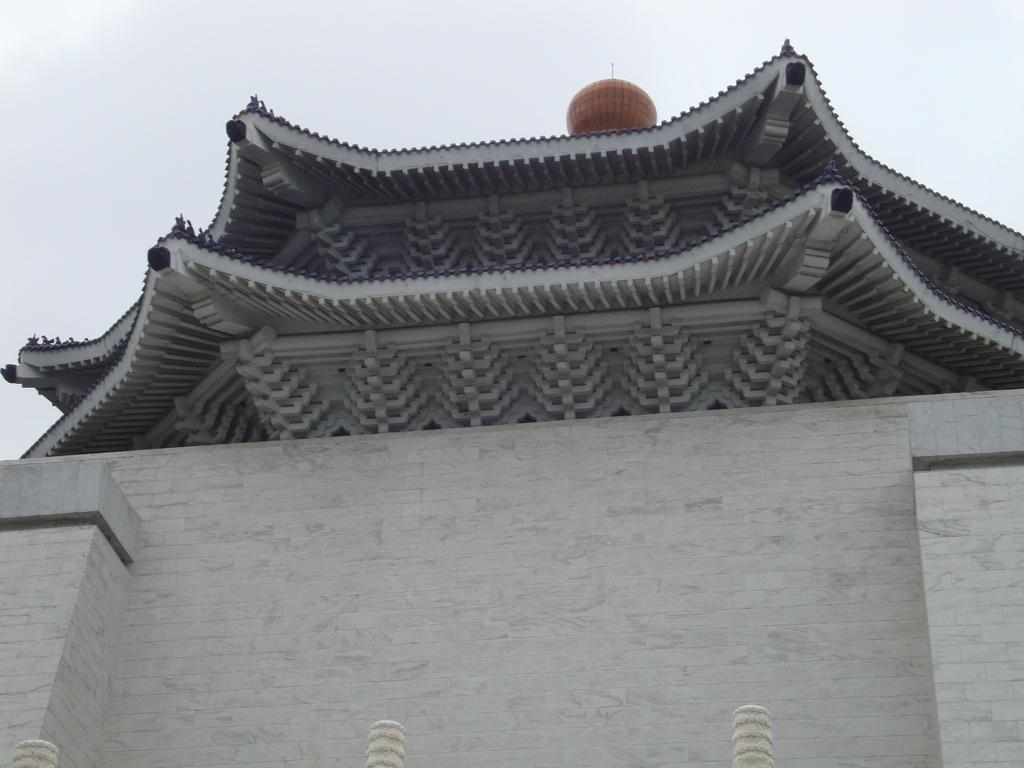What type of building is shown in the image? There is a building with a brick wall in the image. What can be seen on top of the building? There is a round-shaped object on top of the building. What is visible in the background of the image? The sky is visible in the background of the image. How many letters are visible on the brick wall in the image? There are no letters visible on the brick wall in the image. What type of attention is the building receiving in the image? The image does not indicate any specific type of attention the building is receiving. 